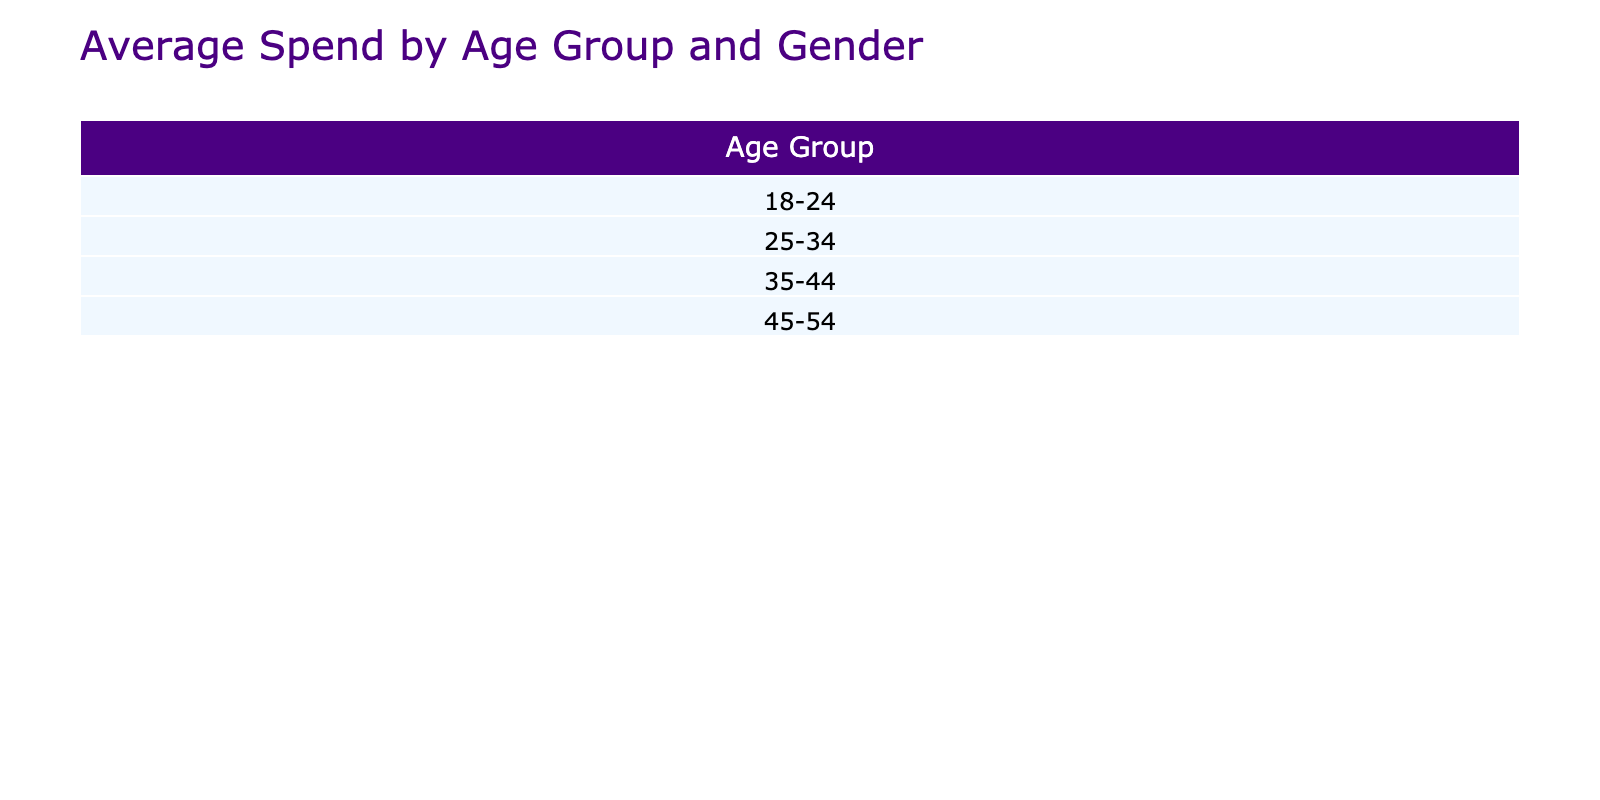What is the average spend for male customers in the 25-34 age group? The table shows the average spend for male customers in the 25-34 age group. Referring to the table, the average spend listed is $200.
Answer: $200 What is the average spend for female customers in the 18-24 age group? The table indicates that there are no female customers in the 18-24 age group, hence the average spend cannot be determined from the data provided.
Answer: Not available Is the average spend for male customers higher than for female customers in the 35-44 age group? By examining the table, the average spend for male customers in the 35-44 age group is $325, while for female customers, it is not available (no entries). Therefore, we cannot say that it is lower or higher.
Answer: Yes, for males it is higher What’s the sum of average spends for all female customers? From the table, the average spends for female customers are $250 (25-34, Rev'It), $100 (18-24, Icon), and $200 (25-34, Dainese), totaling $250 + $100 + $200 = $550.
Answer: $550 Which age group has male customers spending the most on average? The highest spend for male customers, according to the table, is in the 35-44 age group with an average spend of $325, as compared to all other age groups listed.
Answer: 35-44 age group How many male customers have an average spend of over $300? Referring to the table, the male customers with an average spend over $300 are in the 35-44 age group ($325) and another in the 35-44 age group ($350). Consequently, there are two male customers who fall in this category.
Answer: 2 What is the difference in average spending between male customers aged 18-24 and those aged 35-44? The average spend for male customers aged 18-24 is $150, while for those aged 35-44, it is $325. The difference is $325 - $150 = $175.
Answer: $175 Is the average spend for riding jackets higher than for riding boots? The average spending for riding jackets is $200 (based on male customers) and for riding boots is $100 (based on female customers). Thus, the average spending for riding jackets is higher than for riding boots.
Answer: Yes, higher 